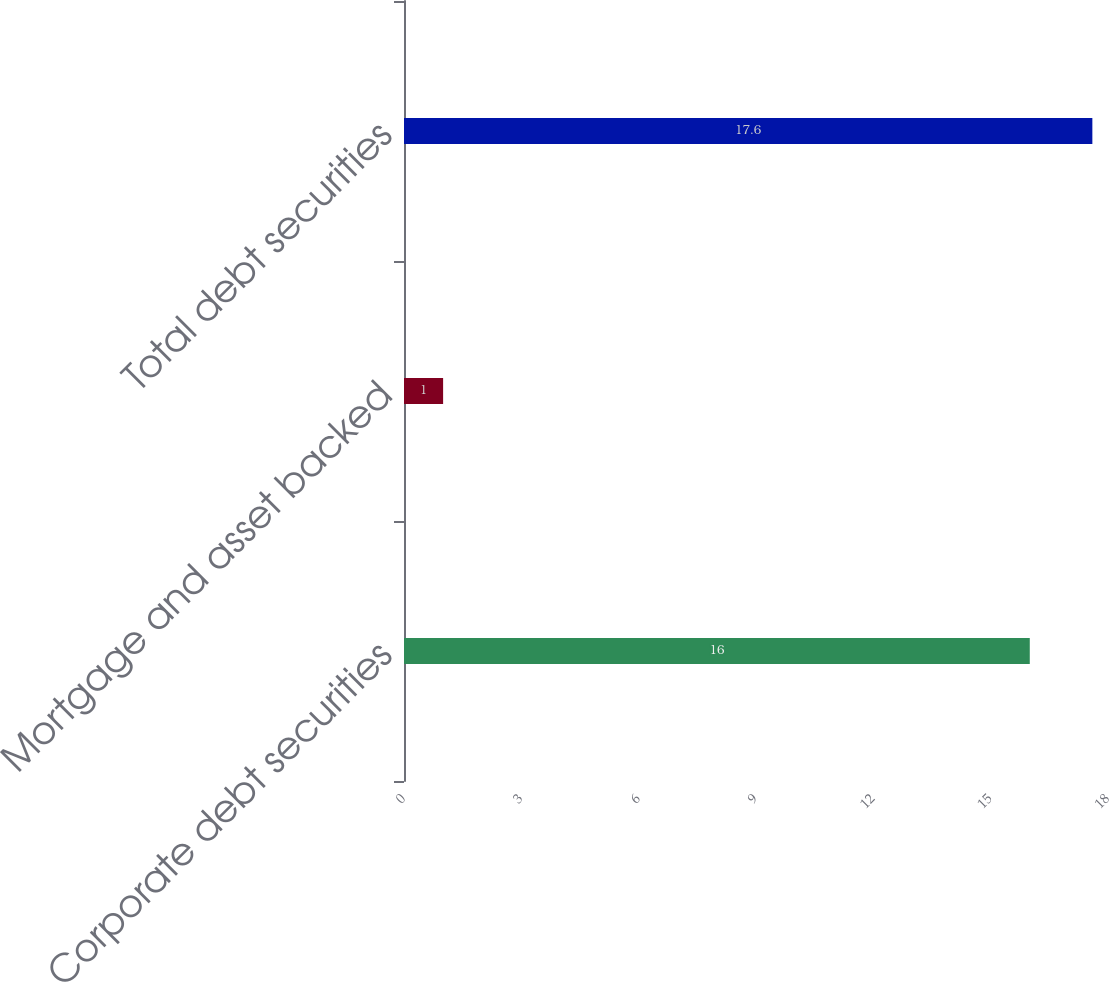Convert chart. <chart><loc_0><loc_0><loc_500><loc_500><bar_chart><fcel>Corporate debt securities<fcel>Mortgage and asset backed<fcel>Total debt securities<nl><fcel>16<fcel>1<fcel>17.6<nl></chart> 